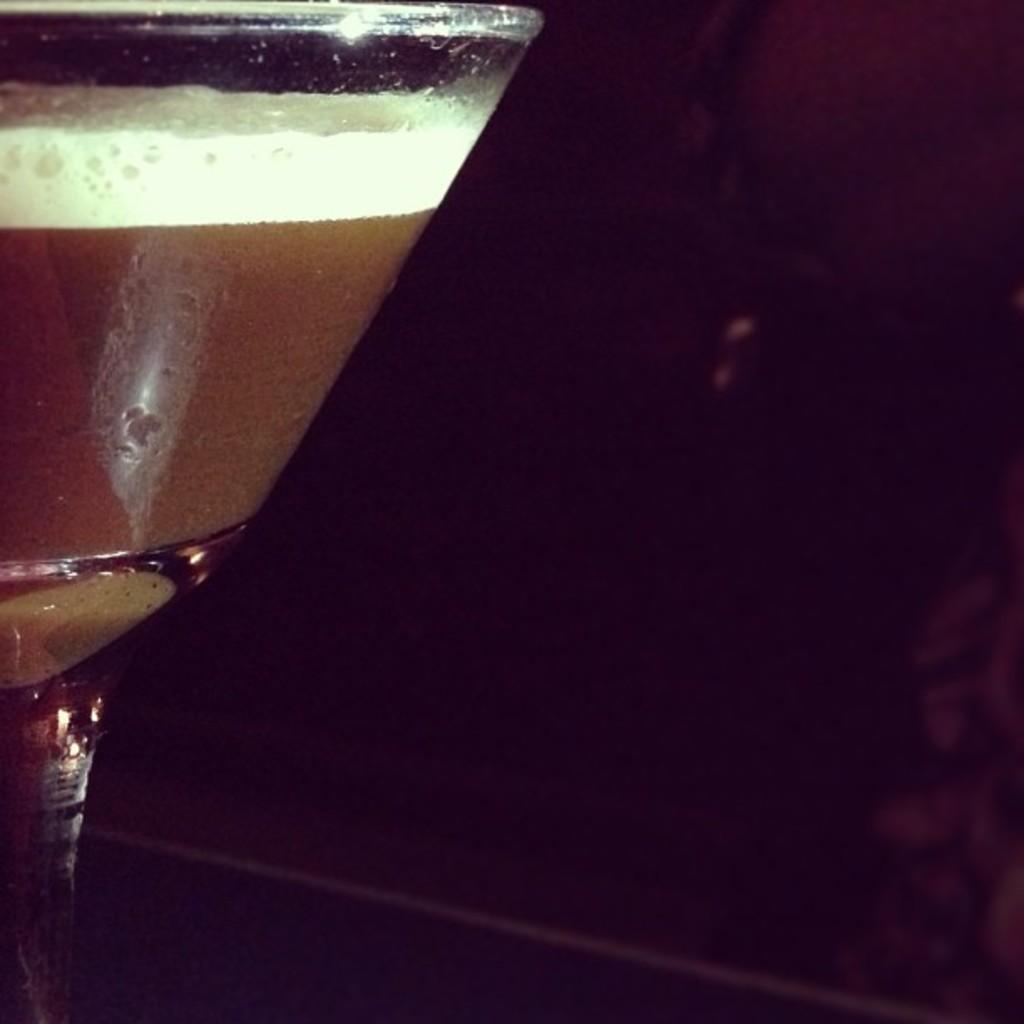What is located in the foreground of the image? There is a glass in the foreground of the image. What is inside the glass? There is a drink in the glass. What color is the background of the image? The background of the image is black in color. How does the wind affect the glass in the image? There is no wind present in the image, so it does not affect the glass. 